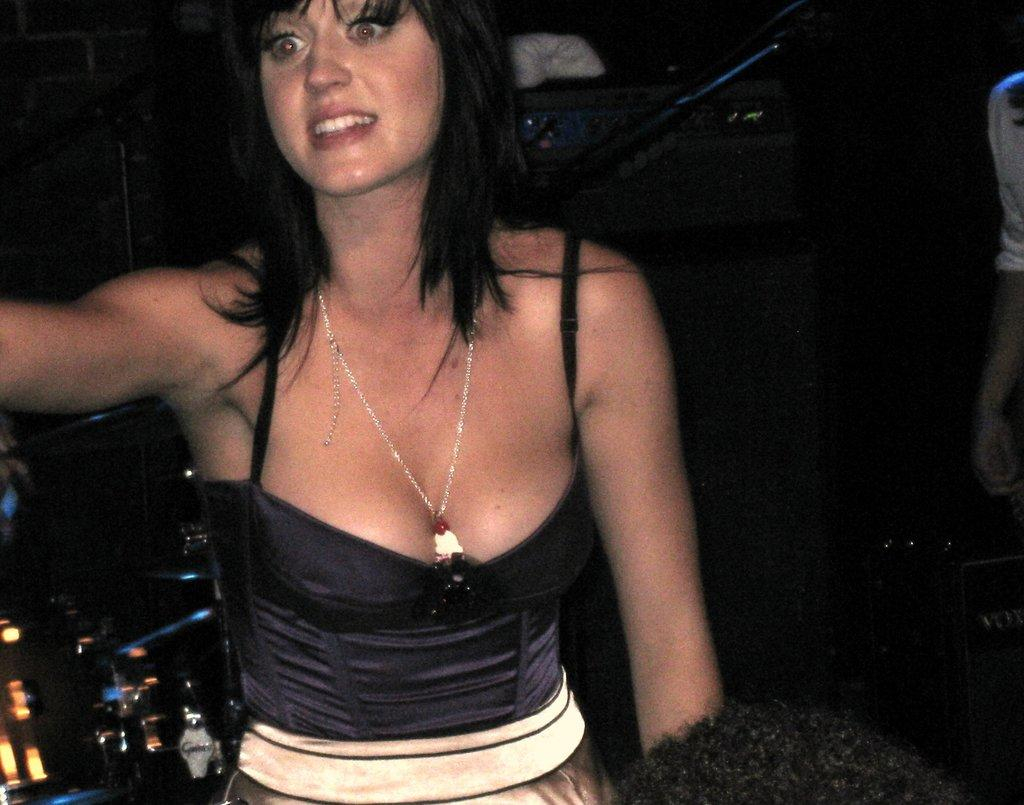Who is present in the image? There is a woman in the image. What type of waste can be seen in the image? There is no waste present in the image; it only features a woman. What type of destruction is depicted in the image? There is no destruction depicted in the image; it only features a woman. 